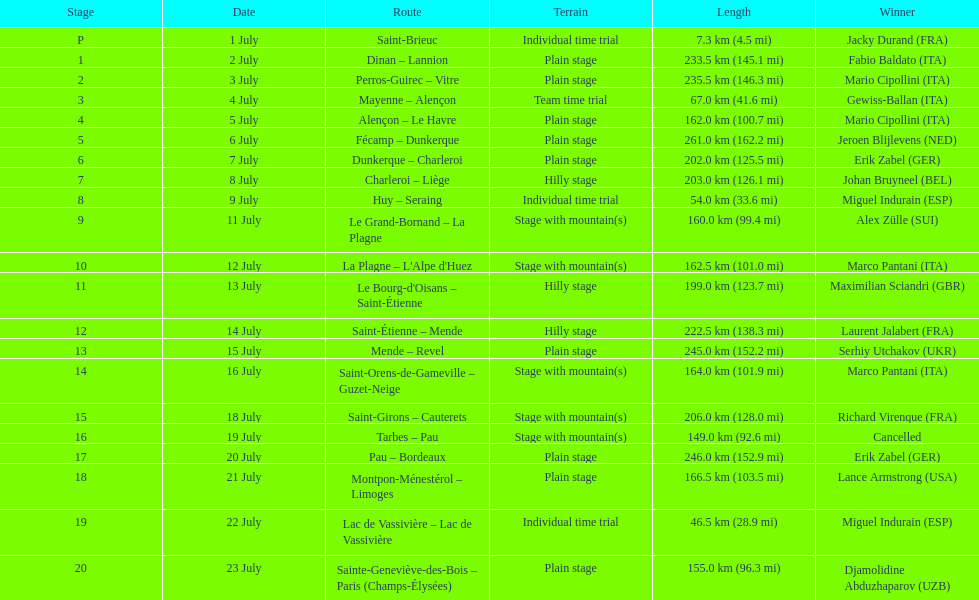What is the additional distance covered in the 20th stage of the tour de france when compared to the 19th stage? 108.5 km. 